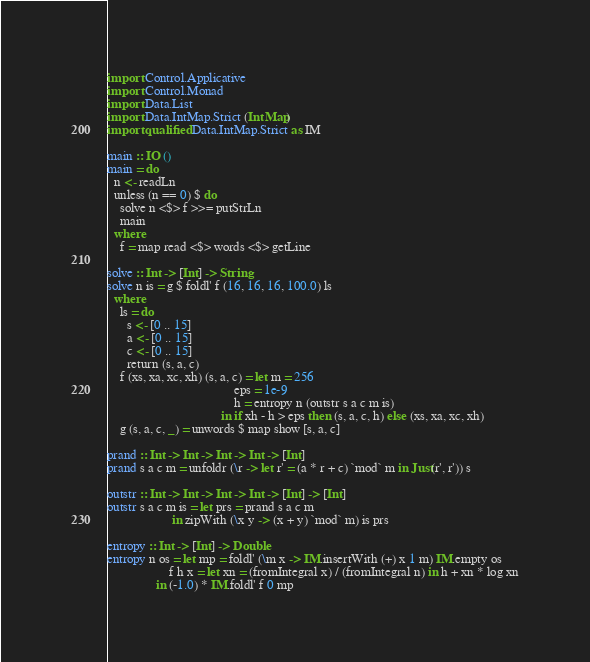<code> <loc_0><loc_0><loc_500><loc_500><_Haskell_>import Control.Applicative
import Control.Monad
import Data.List
import Data.IntMap.Strict (IntMap)
import qualified Data.IntMap.Strict as IM

main :: IO ()
main = do
  n <- readLn
  unless (n == 0) $ do
    solve n <$> f >>= putStrLn
    main
  where
    f = map read <$> words <$> getLine

solve :: Int -> [Int] -> String
solve n is = g $ foldl' f (16, 16, 16, 100.0) ls
  where
    ls = do
      s <- [0 .. 15]
      a <- [0 .. 15]
      c <- [0 .. 15]
      return (s, a, c)
    f (xs, xa, xc, xh) (s, a, c) = let m = 256
                                       eps = 1e-9
                                       h = entropy n (outstr s a c m is)
                                   in if xh - h > eps then (s, a, c, h) else (xs, xa, xc, xh)
    g (s, a, c, _) = unwords $ map show [s, a, c]

prand :: Int -> Int -> Int -> Int -> [Int]
prand s a c m = unfoldr (\r -> let r' = (a * r + c) `mod` m in Just(r', r')) s

outstr :: Int -> Int -> Int -> Int -> [Int] -> [Int]
outstr s a c m is = let prs = prand s a c m
                    in zipWith (\x y -> (x + y) `mod` m) is prs

entropy :: Int -> [Int] -> Double
entropy n os = let mp = foldl' (\m x -> IM.insertWith (+) x 1 m) IM.empty os
                   f h x = let xn = (fromIntegral x) / (fromIntegral n) in h + xn * log xn
               in (-1.0) * IM.foldl' f 0 mp

</code> 